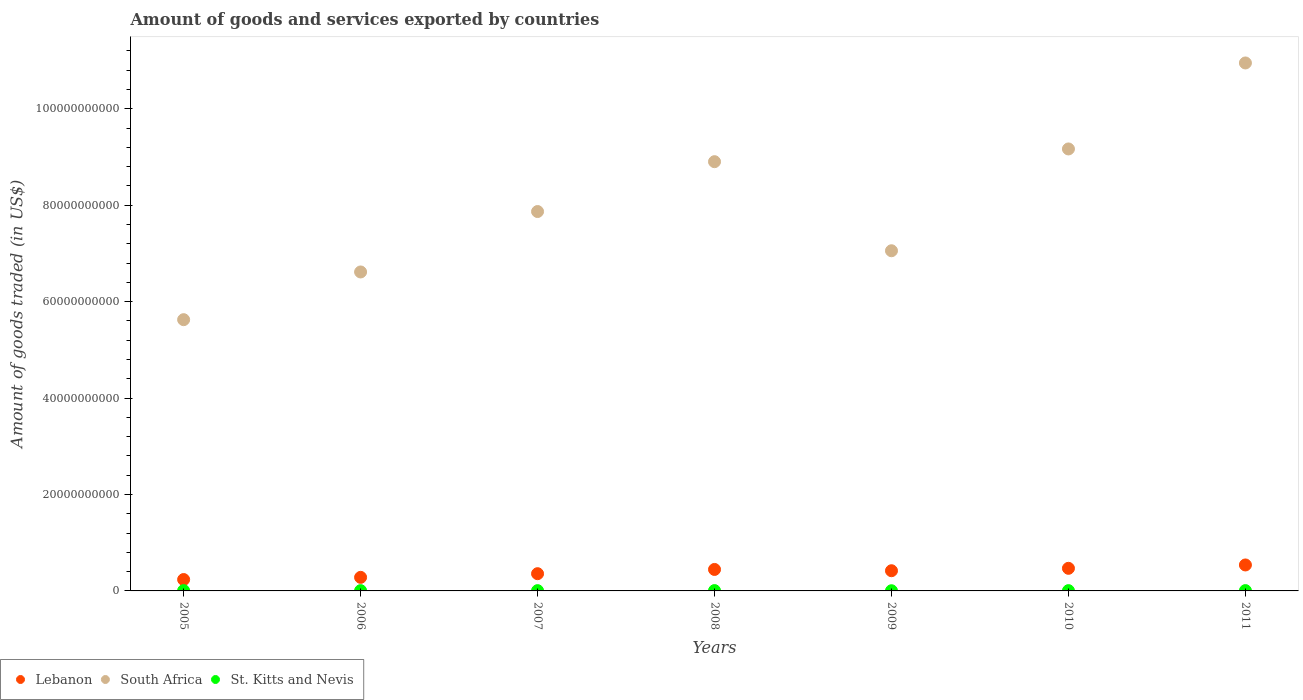What is the total amount of goods and services exported in Lebanon in 2011?
Provide a succinct answer. 5.39e+09. Across all years, what is the maximum total amount of goods and services exported in Lebanon?
Offer a very short reply. 5.39e+09. Across all years, what is the minimum total amount of goods and services exported in South Africa?
Make the answer very short. 5.63e+1. In which year was the total amount of goods and services exported in St. Kitts and Nevis maximum?
Provide a succinct answer. 2008. What is the total total amount of goods and services exported in South Africa in the graph?
Provide a succinct answer. 5.62e+11. What is the difference between the total amount of goods and services exported in Lebanon in 2008 and that in 2009?
Your answer should be very brief. 2.67e+08. What is the difference between the total amount of goods and services exported in St. Kitts and Nevis in 2005 and the total amount of goods and services exported in Lebanon in 2010?
Your answer should be very brief. -4.63e+09. What is the average total amount of goods and services exported in Lebanon per year?
Your answer should be compact. 3.92e+09. In the year 2005, what is the difference between the total amount of goods and services exported in South Africa and total amount of goods and services exported in Lebanon?
Give a very brief answer. 5.39e+1. What is the ratio of the total amount of goods and services exported in South Africa in 2010 to that in 2011?
Provide a short and direct response. 0.84. Is the difference between the total amount of goods and services exported in South Africa in 2007 and 2011 greater than the difference between the total amount of goods and services exported in Lebanon in 2007 and 2011?
Ensure brevity in your answer.  No. What is the difference between the highest and the second highest total amount of goods and services exported in St. Kitts and Nevis?
Your answer should be compact. 1.15e+06. What is the difference between the highest and the lowest total amount of goods and services exported in South Africa?
Keep it short and to the point. 5.32e+1. Is the sum of the total amount of goods and services exported in South Africa in 2005 and 2007 greater than the maximum total amount of goods and services exported in St. Kitts and Nevis across all years?
Your response must be concise. Yes. Is it the case that in every year, the sum of the total amount of goods and services exported in Lebanon and total amount of goods and services exported in St. Kitts and Nevis  is greater than the total amount of goods and services exported in South Africa?
Your response must be concise. No. Is the total amount of goods and services exported in St. Kitts and Nevis strictly greater than the total amount of goods and services exported in Lebanon over the years?
Your answer should be compact. No. Is the total amount of goods and services exported in Lebanon strictly less than the total amount of goods and services exported in St. Kitts and Nevis over the years?
Keep it short and to the point. No. How many dotlines are there?
Your answer should be compact. 3. How many years are there in the graph?
Make the answer very short. 7. What is the difference between two consecutive major ticks on the Y-axis?
Your response must be concise. 2.00e+1. Does the graph contain any zero values?
Make the answer very short. No. Does the graph contain grids?
Keep it short and to the point. No. How many legend labels are there?
Make the answer very short. 3. What is the title of the graph?
Your answer should be very brief. Amount of goods and services exported by countries. What is the label or title of the X-axis?
Offer a terse response. Years. What is the label or title of the Y-axis?
Ensure brevity in your answer.  Amount of goods traded (in US$). What is the Amount of goods traded (in US$) in Lebanon in 2005?
Give a very brief answer. 2.36e+09. What is the Amount of goods traded (in US$) in South Africa in 2005?
Your answer should be very brief. 5.63e+1. What is the Amount of goods traded (in US$) in St. Kitts and Nevis in 2005?
Provide a short and direct response. 6.34e+07. What is the Amount of goods traded (in US$) of Lebanon in 2006?
Your answer should be compact. 2.81e+09. What is the Amount of goods traded (in US$) of South Africa in 2006?
Make the answer very short. 6.62e+1. What is the Amount of goods traded (in US$) in St. Kitts and Nevis in 2006?
Your answer should be very brief. 5.82e+07. What is the Amount of goods traded (in US$) of Lebanon in 2007?
Your response must be concise. 3.57e+09. What is the Amount of goods traded (in US$) of South Africa in 2007?
Your answer should be compact. 7.87e+1. What is the Amount of goods traded (in US$) in St. Kitts and Nevis in 2007?
Make the answer very short. 5.75e+07. What is the Amount of goods traded (in US$) in Lebanon in 2008?
Provide a short and direct response. 4.45e+09. What is the Amount of goods traded (in US$) in South Africa in 2008?
Offer a very short reply. 8.90e+1. What is the Amount of goods traded (in US$) in St. Kitts and Nevis in 2008?
Give a very brief answer. 6.89e+07. What is the Amount of goods traded (in US$) of Lebanon in 2009?
Provide a succinct answer. 4.19e+09. What is the Amount of goods traded (in US$) of South Africa in 2009?
Offer a terse response. 7.06e+1. What is the Amount of goods traded (in US$) in St. Kitts and Nevis in 2009?
Ensure brevity in your answer.  3.74e+07. What is the Amount of goods traded (in US$) of Lebanon in 2010?
Keep it short and to the point. 4.69e+09. What is the Amount of goods traded (in US$) in South Africa in 2010?
Your answer should be very brief. 9.17e+1. What is the Amount of goods traded (in US$) in St. Kitts and Nevis in 2010?
Your answer should be compact. 5.79e+07. What is the Amount of goods traded (in US$) of Lebanon in 2011?
Offer a terse response. 5.39e+09. What is the Amount of goods traded (in US$) in South Africa in 2011?
Ensure brevity in your answer.  1.10e+11. What is the Amount of goods traded (in US$) of St. Kitts and Nevis in 2011?
Make the answer very short. 6.77e+07. Across all years, what is the maximum Amount of goods traded (in US$) of Lebanon?
Ensure brevity in your answer.  5.39e+09. Across all years, what is the maximum Amount of goods traded (in US$) in South Africa?
Offer a terse response. 1.10e+11. Across all years, what is the maximum Amount of goods traded (in US$) of St. Kitts and Nevis?
Give a very brief answer. 6.89e+07. Across all years, what is the minimum Amount of goods traded (in US$) in Lebanon?
Your response must be concise. 2.36e+09. Across all years, what is the minimum Amount of goods traded (in US$) in South Africa?
Your answer should be very brief. 5.63e+1. Across all years, what is the minimum Amount of goods traded (in US$) in St. Kitts and Nevis?
Offer a terse response. 3.74e+07. What is the total Amount of goods traded (in US$) in Lebanon in the graph?
Your response must be concise. 2.75e+1. What is the total Amount of goods traded (in US$) of South Africa in the graph?
Offer a very short reply. 5.62e+11. What is the total Amount of goods traded (in US$) of St. Kitts and Nevis in the graph?
Provide a succinct answer. 4.11e+08. What is the difference between the Amount of goods traded (in US$) in Lebanon in 2005 and that in 2006?
Provide a short and direct response. -4.53e+08. What is the difference between the Amount of goods traded (in US$) of South Africa in 2005 and that in 2006?
Offer a very short reply. -9.90e+09. What is the difference between the Amount of goods traded (in US$) in St. Kitts and Nevis in 2005 and that in 2006?
Your answer should be compact. 5.23e+06. What is the difference between the Amount of goods traded (in US$) of Lebanon in 2005 and that in 2007?
Your response must be concise. -1.21e+09. What is the difference between the Amount of goods traded (in US$) in South Africa in 2005 and that in 2007?
Make the answer very short. -2.24e+1. What is the difference between the Amount of goods traded (in US$) in St. Kitts and Nevis in 2005 and that in 2007?
Make the answer very short. 5.92e+06. What is the difference between the Amount of goods traded (in US$) of Lebanon in 2005 and that in 2008?
Make the answer very short. -2.09e+09. What is the difference between the Amount of goods traded (in US$) of South Africa in 2005 and that in 2008?
Your answer should be compact. -3.28e+1. What is the difference between the Amount of goods traded (in US$) in St. Kitts and Nevis in 2005 and that in 2008?
Your answer should be very brief. -5.43e+06. What is the difference between the Amount of goods traded (in US$) of Lebanon in 2005 and that in 2009?
Provide a short and direct response. -1.83e+09. What is the difference between the Amount of goods traded (in US$) in South Africa in 2005 and that in 2009?
Give a very brief answer. -1.43e+1. What is the difference between the Amount of goods traded (in US$) of St. Kitts and Nevis in 2005 and that in 2009?
Make the answer very short. 2.60e+07. What is the difference between the Amount of goods traded (in US$) of Lebanon in 2005 and that in 2010?
Provide a succinct answer. -2.33e+09. What is the difference between the Amount of goods traded (in US$) of South Africa in 2005 and that in 2010?
Offer a very short reply. -3.54e+1. What is the difference between the Amount of goods traded (in US$) of St. Kitts and Nevis in 2005 and that in 2010?
Your answer should be compact. 5.54e+06. What is the difference between the Amount of goods traded (in US$) in Lebanon in 2005 and that in 2011?
Make the answer very short. -3.02e+09. What is the difference between the Amount of goods traded (in US$) in South Africa in 2005 and that in 2011?
Make the answer very short. -5.32e+1. What is the difference between the Amount of goods traded (in US$) of St. Kitts and Nevis in 2005 and that in 2011?
Keep it short and to the point. -4.27e+06. What is the difference between the Amount of goods traded (in US$) of Lebanon in 2006 and that in 2007?
Offer a very short reply. -7.60e+08. What is the difference between the Amount of goods traded (in US$) in South Africa in 2006 and that in 2007?
Offer a terse response. -1.25e+1. What is the difference between the Amount of goods traded (in US$) in St. Kitts and Nevis in 2006 and that in 2007?
Your answer should be very brief. 6.88e+05. What is the difference between the Amount of goods traded (in US$) of Lebanon in 2006 and that in 2008?
Provide a short and direct response. -1.64e+09. What is the difference between the Amount of goods traded (in US$) in South Africa in 2006 and that in 2008?
Your answer should be compact. -2.29e+1. What is the difference between the Amount of goods traded (in US$) of St. Kitts and Nevis in 2006 and that in 2008?
Provide a succinct answer. -1.07e+07. What is the difference between the Amount of goods traded (in US$) of Lebanon in 2006 and that in 2009?
Your answer should be compact. -1.37e+09. What is the difference between the Amount of goods traded (in US$) in South Africa in 2006 and that in 2009?
Make the answer very short. -4.40e+09. What is the difference between the Amount of goods traded (in US$) in St. Kitts and Nevis in 2006 and that in 2009?
Your answer should be very brief. 2.08e+07. What is the difference between the Amount of goods traded (in US$) of Lebanon in 2006 and that in 2010?
Ensure brevity in your answer.  -1.87e+09. What is the difference between the Amount of goods traded (in US$) of South Africa in 2006 and that in 2010?
Your answer should be compact. -2.55e+1. What is the difference between the Amount of goods traded (in US$) of St. Kitts and Nevis in 2006 and that in 2010?
Your answer should be compact. 3.13e+05. What is the difference between the Amount of goods traded (in US$) of Lebanon in 2006 and that in 2011?
Your answer should be compact. -2.57e+09. What is the difference between the Amount of goods traded (in US$) of South Africa in 2006 and that in 2011?
Provide a short and direct response. -4.33e+1. What is the difference between the Amount of goods traded (in US$) of St. Kitts and Nevis in 2006 and that in 2011?
Keep it short and to the point. -9.50e+06. What is the difference between the Amount of goods traded (in US$) of Lebanon in 2007 and that in 2008?
Offer a very short reply. -8.79e+08. What is the difference between the Amount of goods traded (in US$) in South Africa in 2007 and that in 2008?
Provide a succinct answer. -1.03e+1. What is the difference between the Amount of goods traded (in US$) in St. Kitts and Nevis in 2007 and that in 2008?
Ensure brevity in your answer.  -1.13e+07. What is the difference between the Amount of goods traded (in US$) in Lebanon in 2007 and that in 2009?
Ensure brevity in your answer.  -6.13e+08. What is the difference between the Amount of goods traded (in US$) in South Africa in 2007 and that in 2009?
Make the answer very short. 8.14e+09. What is the difference between the Amount of goods traded (in US$) in St. Kitts and Nevis in 2007 and that in 2009?
Provide a succinct answer. 2.01e+07. What is the difference between the Amount of goods traded (in US$) in Lebanon in 2007 and that in 2010?
Offer a terse response. -1.11e+09. What is the difference between the Amount of goods traded (in US$) of South Africa in 2007 and that in 2010?
Ensure brevity in your answer.  -1.30e+1. What is the difference between the Amount of goods traded (in US$) of St. Kitts and Nevis in 2007 and that in 2010?
Provide a short and direct response. -3.75e+05. What is the difference between the Amount of goods traded (in US$) of Lebanon in 2007 and that in 2011?
Keep it short and to the point. -1.81e+09. What is the difference between the Amount of goods traded (in US$) of South Africa in 2007 and that in 2011?
Provide a short and direct response. -3.08e+1. What is the difference between the Amount of goods traded (in US$) of St. Kitts and Nevis in 2007 and that in 2011?
Ensure brevity in your answer.  -1.02e+07. What is the difference between the Amount of goods traded (in US$) in Lebanon in 2008 and that in 2009?
Your response must be concise. 2.67e+08. What is the difference between the Amount of goods traded (in US$) in South Africa in 2008 and that in 2009?
Give a very brief answer. 1.85e+1. What is the difference between the Amount of goods traded (in US$) in St. Kitts and Nevis in 2008 and that in 2009?
Provide a short and direct response. 3.14e+07. What is the difference between the Amount of goods traded (in US$) in Lebanon in 2008 and that in 2010?
Keep it short and to the point. -2.35e+08. What is the difference between the Amount of goods traded (in US$) in South Africa in 2008 and that in 2010?
Make the answer very short. -2.64e+09. What is the difference between the Amount of goods traded (in US$) of St. Kitts and Nevis in 2008 and that in 2010?
Offer a terse response. 1.10e+07. What is the difference between the Amount of goods traded (in US$) in Lebanon in 2008 and that in 2011?
Your response must be concise. -9.32e+08. What is the difference between the Amount of goods traded (in US$) in South Africa in 2008 and that in 2011?
Provide a short and direct response. -2.05e+1. What is the difference between the Amount of goods traded (in US$) in St. Kitts and Nevis in 2008 and that in 2011?
Your answer should be very brief. 1.15e+06. What is the difference between the Amount of goods traded (in US$) in Lebanon in 2009 and that in 2010?
Your answer should be compact. -5.02e+08. What is the difference between the Amount of goods traded (in US$) of South Africa in 2009 and that in 2010?
Your answer should be very brief. -2.11e+1. What is the difference between the Amount of goods traded (in US$) in St. Kitts and Nevis in 2009 and that in 2010?
Offer a terse response. -2.05e+07. What is the difference between the Amount of goods traded (in US$) of Lebanon in 2009 and that in 2011?
Provide a succinct answer. -1.20e+09. What is the difference between the Amount of goods traded (in US$) in South Africa in 2009 and that in 2011?
Your answer should be compact. -3.90e+1. What is the difference between the Amount of goods traded (in US$) of St. Kitts and Nevis in 2009 and that in 2011?
Provide a succinct answer. -3.03e+07. What is the difference between the Amount of goods traded (in US$) of Lebanon in 2010 and that in 2011?
Your response must be concise. -6.97e+08. What is the difference between the Amount of goods traded (in US$) in South Africa in 2010 and that in 2011?
Keep it short and to the point. -1.78e+1. What is the difference between the Amount of goods traded (in US$) of St. Kitts and Nevis in 2010 and that in 2011?
Provide a succinct answer. -9.81e+06. What is the difference between the Amount of goods traded (in US$) in Lebanon in 2005 and the Amount of goods traded (in US$) in South Africa in 2006?
Make the answer very short. -6.38e+1. What is the difference between the Amount of goods traded (in US$) in Lebanon in 2005 and the Amount of goods traded (in US$) in St. Kitts and Nevis in 2006?
Keep it short and to the point. 2.30e+09. What is the difference between the Amount of goods traded (in US$) in South Africa in 2005 and the Amount of goods traded (in US$) in St. Kitts and Nevis in 2006?
Your response must be concise. 5.62e+1. What is the difference between the Amount of goods traded (in US$) of Lebanon in 2005 and the Amount of goods traded (in US$) of South Africa in 2007?
Offer a terse response. -7.63e+1. What is the difference between the Amount of goods traded (in US$) of Lebanon in 2005 and the Amount of goods traded (in US$) of St. Kitts and Nevis in 2007?
Offer a terse response. 2.30e+09. What is the difference between the Amount of goods traded (in US$) of South Africa in 2005 and the Amount of goods traded (in US$) of St. Kitts and Nevis in 2007?
Offer a very short reply. 5.62e+1. What is the difference between the Amount of goods traded (in US$) in Lebanon in 2005 and the Amount of goods traded (in US$) in South Africa in 2008?
Your response must be concise. -8.67e+1. What is the difference between the Amount of goods traded (in US$) of Lebanon in 2005 and the Amount of goods traded (in US$) of St. Kitts and Nevis in 2008?
Offer a terse response. 2.29e+09. What is the difference between the Amount of goods traded (in US$) in South Africa in 2005 and the Amount of goods traded (in US$) in St. Kitts and Nevis in 2008?
Ensure brevity in your answer.  5.62e+1. What is the difference between the Amount of goods traded (in US$) in Lebanon in 2005 and the Amount of goods traded (in US$) in South Africa in 2009?
Make the answer very short. -6.82e+1. What is the difference between the Amount of goods traded (in US$) in Lebanon in 2005 and the Amount of goods traded (in US$) in St. Kitts and Nevis in 2009?
Keep it short and to the point. 2.32e+09. What is the difference between the Amount of goods traded (in US$) in South Africa in 2005 and the Amount of goods traded (in US$) in St. Kitts and Nevis in 2009?
Provide a short and direct response. 5.62e+1. What is the difference between the Amount of goods traded (in US$) of Lebanon in 2005 and the Amount of goods traded (in US$) of South Africa in 2010?
Offer a terse response. -8.93e+1. What is the difference between the Amount of goods traded (in US$) of Lebanon in 2005 and the Amount of goods traded (in US$) of St. Kitts and Nevis in 2010?
Your answer should be very brief. 2.30e+09. What is the difference between the Amount of goods traded (in US$) of South Africa in 2005 and the Amount of goods traded (in US$) of St. Kitts and Nevis in 2010?
Your response must be concise. 5.62e+1. What is the difference between the Amount of goods traded (in US$) of Lebanon in 2005 and the Amount of goods traded (in US$) of South Africa in 2011?
Provide a succinct answer. -1.07e+11. What is the difference between the Amount of goods traded (in US$) in Lebanon in 2005 and the Amount of goods traded (in US$) in St. Kitts and Nevis in 2011?
Make the answer very short. 2.29e+09. What is the difference between the Amount of goods traded (in US$) of South Africa in 2005 and the Amount of goods traded (in US$) of St. Kitts and Nevis in 2011?
Your answer should be compact. 5.62e+1. What is the difference between the Amount of goods traded (in US$) in Lebanon in 2006 and the Amount of goods traded (in US$) in South Africa in 2007?
Offer a very short reply. -7.59e+1. What is the difference between the Amount of goods traded (in US$) in Lebanon in 2006 and the Amount of goods traded (in US$) in St. Kitts and Nevis in 2007?
Give a very brief answer. 2.76e+09. What is the difference between the Amount of goods traded (in US$) in South Africa in 2006 and the Amount of goods traded (in US$) in St. Kitts and Nevis in 2007?
Provide a succinct answer. 6.61e+1. What is the difference between the Amount of goods traded (in US$) of Lebanon in 2006 and the Amount of goods traded (in US$) of South Africa in 2008?
Provide a succinct answer. -8.62e+1. What is the difference between the Amount of goods traded (in US$) of Lebanon in 2006 and the Amount of goods traded (in US$) of St. Kitts and Nevis in 2008?
Keep it short and to the point. 2.74e+09. What is the difference between the Amount of goods traded (in US$) of South Africa in 2006 and the Amount of goods traded (in US$) of St. Kitts and Nevis in 2008?
Provide a succinct answer. 6.61e+1. What is the difference between the Amount of goods traded (in US$) in Lebanon in 2006 and the Amount of goods traded (in US$) in South Africa in 2009?
Make the answer very short. -6.77e+1. What is the difference between the Amount of goods traded (in US$) in Lebanon in 2006 and the Amount of goods traded (in US$) in St. Kitts and Nevis in 2009?
Your response must be concise. 2.78e+09. What is the difference between the Amount of goods traded (in US$) of South Africa in 2006 and the Amount of goods traded (in US$) of St. Kitts and Nevis in 2009?
Offer a terse response. 6.61e+1. What is the difference between the Amount of goods traded (in US$) in Lebanon in 2006 and the Amount of goods traded (in US$) in South Africa in 2010?
Provide a short and direct response. -8.89e+1. What is the difference between the Amount of goods traded (in US$) of Lebanon in 2006 and the Amount of goods traded (in US$) of St. Kitts and Nevis in 2010?
Your response must be concise. 2.76e+09. What is the difference between the Amount of goods traded (in US$) of South Africa in 2006 and the Amount of goods traded (in US$) of St. Kitts and Nevis in 2010?
Keep it short and to the point. 6.61e+1. What is the difference between the Amount of goods traded (in US$) of Lebanon in 2006 and the Amount of goods traded (in US$) of South Africa in 2011?
Your response must be concise. -1.07e+11. What is the difference between the Amount of goods traded (in US$) of Lebanon in 2006 and the Amount of goods traded (in US$) of St. Kitts and Nevis in 2011?
Ensure brevity in your answer.  2.75e+09. What is the difference between the Amount of goods traded (in US$) in South Africa in 2006 and the Amount of goods traded (in US$) in St. Kitts and Nevis in 2011?
Make the answer very short. 6.61e+1. What is the difference between the Amount of goods traded (in US$) in Lebanon in 2007 and the Amount of goods traded (in US$) in South Africa in 2008?
Provide a short and direct response. -8.55e+1. What is the difference between the Amount of goods traded (in US$) in Lebanon in 2007 and the Amount of goods traded (in US$) in St. Kitts and Nevis in 2008?
Your response must be concise. 3.51e+09. What is the difference between the Amount of goods traded (in US$) of South Africa in 2007 and the Amount of goods traded (in US$) of St. Kitts and Nevis in 2008?
Ensure brevity in your answer.  7.86e+1. What is the difference between the Amount of goods traded (in US$) in Lebanon in 2007 and the Amount of goods traded (in US$) in South Africa in 2009?
Your response must be concise. -6.70e+1. What is the difference between the Amount of goods traded (in US$) in Lebanon in 2007 and the Amount of goods traded (in US$) in St. Kitts and Nevis in 2009?
Ensure brevity in your answer.  3.54e+09. What is the difference between the Amount of goods traded (in US$) in South Africa in 2007 and the Amount of goods traded (in US$) in St. Kitts and Nevis in 2009?
Give a very brief answer. 7.87e+1. What is the difference between the Amount of goods traded (in US$) of Lebanon in 2007 and the Amount of goods traded (in US$) of South Africa in 2010?
Offer a terse response. -8.81e+1. What is the difference between the Amount of goods traded (in US$) of Lebanon in 2007 and the Amount of goods traded (in US$) of St. Kitts and Nevis in 2010?
Provide a short and direct response. 3.52e+09. What is the difference between the Amount of goods traded (in US$) in South Africa in 2007 and the Amount of goods traded (in US$) in St. Kitts and Nevis in 2010?
Your answer should be very brief. 7.86e+1. What is the difference between the Amount of goods traded (in US$) in Lebanon in 2007 and the Amount of goods traded (in US$) in South Africa in 2011?
Provide a succinct answer. -1.06e+11. What is the difference between the Amount of goods traded (in US$) in Lebanon in 2007 and the Amount of goods traded (in US$) in St. Kitts and Nevis in 2011?
Your answer should be very brief. 3.51e+09. What is the difference between the Amount of goods traded (in US$) in South Africa in 2007 and the Amount of goods traded (in US$) in St. Kitts and Nevis in 2011?
Keep it short and to the point. 7.86e+1. What is the difference between the Amount of goods traded (in US$) in Lebanon in 2008 and the Amount of goods traded (in US$) in South Africa in 2009?
Keep it short and to the point. -6.61e+1. What is the difference between the Amount of goods traded (in US$) of Lebanon in 2008 and the Amount of goods traded (in US$) of St. Kitts and Nevis in 2009?
Offer a terse response. 4.42e+09. What is the difference between the Amount of goods traded (in US$) in South Africa in 2008 and the Amount of goods traded (in US$) in St. Kitts and Nevis in 2009?
Offer a terse response. 8.90e+1. What is the difference between the Amount of goods traded (in US$) of Lebanon in 2008 and the Amount of goods traded (in US$) of South Africa in 2010?
Your answer should be compact. -8.72e+1. What is the difference between the Amount of goods traded (in US$) in Lebanon in 2008 and the Amount of goods traded (in US$) in St. Kitts and Nevis in 2010?
Your answer should be compact. 4.40e+09. What is the difference between the Amount of goods traded (in US$) of South Africa in 2008 and the Amount of goods traded (in US$) of St. Kitts and Nevis in 2010?
Give a very brief answer. 8.90e+1. What is the difference between the Amount of goods traded (in US$) in Lebanon in 2008 and the Amount of goods traded (in US$) in South Africa in 2011?
Your answer should be compact. -1.05e+11. What is the difference between the Amount of goods traded (in US$) of Lebanon in 2008 and the Amount of goods traded (in US$) of St. Kitts and Nevis in 2011?
Your answer should be compact. 4.39e+09. What is the difference between the Amount of goods traded (in US$) of South Africa in 2008 and the Amount of goods traded (in US$) of St. Kitts and Nevis in 2011?
Make the answer very short. 8.90e+1. What is the difference between the Amount of goods traded (in US$) of Lebanon in 2009 and the Amount of goods traded (in US$) of South Africa in 2010?
Make the answer very short. -8.75e+1. What is the difference between the Amount of goods traded (in US$) in Lebanon in 2009 and the Amount of goods traded (in US$) in St. Kitts and Nevis in 2010?
Offer a terse response. 4.13e+09. What is the difference between the Amount of goods traded (in US$) in South Africa in 2009 and the Amount of goods traded (in US$) in St. Kitts and Nevis in 2010?
Provide a succinct answer. 7.05e+1. What is the difference between the Amount of goods traded (in US$) in Lebanon in 2009 and the Amount of goods traded (in US$) in South Africa in 2011?
Your answer should be compact. -1.05e+11. What is the difference between the Amount of goods traded (in US$) of Lebanon in 2009 and the Amount of goods traded (in US$) of St. Kitts and Nevis in 2011?
Your answer should be compact. 4.12e+09. What is the difference between the Amount of goods traded (in US$) of South Africa in 2009 and the Amount of goods traded (in US$) of St. Kitts and Nevis in 2011?
Make the answer very short. 7.05e+1. What is the difference between the Amount of goods traded (in US$) in Lebanon in 2010 and the Amount of goods traded (in US$) in South Africa in 2011?
Offer a terse response. -1.05e+11. What is the difference between the Amount of goods traded (in US$) in Lebanon in 2010 and the Amount of goods traded (in US$) in St. Kitts and Nevis in 2011?
Offer a terse response. 4.62e+09. What is the difference between the Amount of goods traded (in US$) of South Africa in 2010 and the Amount of goods traded (in US$) of St. Kitts and Nevis in 2011?
Make the answer very short. 9.16e+1. What is the average Amount of goods traded (in US$) of Lebanon per year?
Your answer should be compact. 3.92e+09. What is the average Amount of goods traded (in US$) in South Africa per year?
Your answer should be very brief. 8.03e+1. What is the average Amount of goods traded (in US$) of St. Kitts and Nevis per year?
Give a very brief answer. 5.87e+07. In the year 2005, what is the difference between the Amount of goods traded (in US$) of Lebanon and Amount of goods traded (in US$) of South Africa?
Your answer should be very brief. -5.39e+1. In the year 2005, what is the difference between the Amount of goods traded (in US$) of Lebanon and Amount of goods traded (in US$) of St. Kitts and Nevis?
Make the answer very short. 2.30e+09. In the year 2005, what is the difference between the Amount of goods traded (in US$) in South Africa and Amount of goods traded (in US$) in St. Kitts and Nevis?
Provide a short and direct response. 5.62e+1. In the year 2006, what is the difference between the Amount of goods traded (in US$) in Lebanon and Amount of goods traded (in US$) in South Africa?
Offer a very short reply. -6.33e+1. In the year 2006, what is the difference between the Amount of goods traded (in US$) of Lebanon and Amount of goods traded (in US$) of St. Kitts and Nevis?
Provide a short and direct response. 2.76e+09. In the year 2006, what is the difference between the Amount of goods traded (in US$) of South Africa and Amount of goods traded (in US$) of St. Kitts and Nevis?
Provide a succinct answer. 6.61e+1. In the year 2007, what is the difference between the Amount of goods traded (in US$) of Lebanon and Amount of goods traded (in US$) of South Africa?
Your answer should be very brief. -7.51e+1. In the year 2007, what is the difference between the Amount of goods traded (in US$) in Lebanon and Amount of goods traded (in US$) in St. Kitts and Nevis?
Give a very brief answer. 3.52e+09. In the year 2007, what is the difference between the Amount of goods traded (in US$) of South Africa and Amount of goods traded (in US$) of St. Kitts and Nevis?
Keep it short and to the point. 7.86e+1. In the year 2008, what is the difference between the Amount of goods traded (in US$) of Lebanon and Amount of goods traded (in US$) of South Africa?
Offer a very short reply. -8.46e+1. In the year 2008, what is the difference between the Amount of goods traded (in US$) of Lebanon and Amount of goods traded (in US$) of St. Kitts and Nevis?
Your response must be concise. 4.38e+09. In the year 2008, what is the difference between the Amount of goods traded (in US$) in South Africa and Amount of goods traded (in US$) in St. Kitts and Nevis?
Offer a very short reply. 8.90e+1. In the year 2009, what is the difference between the Amount of goods traded (in US$) of Lebanon and Amount of goods traded (in US$) of South Africa?
Keep it short and to the point. -6.64e+1. In the year 2009, what is the difference between the Amount of goods traded (in US$) in Lebanon and Amount of goods traded (in US$) in St. Kitts and Nevis?
Ensure brevity in your answer.  4.15e+09. In the year 2009, what is the difference between the Amount of goods traded (in US$) of South Africa and Amount of goods traded (in US$) of St. Kitts and Nevis?
Provide a succinct answer. 7.05e+1. In the year 2010, what is the difference between the Amount of goods traded (in US$) in Lebanon and Amount of goods traded (in US$) in South Africa?
Provide a short and direct response. -8.70e+1. In the year 2010, what is the difference between the Amount of goods traded (in US$) in Lebanon and Amount of goods traded (in US$) in St. Kitts and Nevis?
Your answer should be very brief. 4.63e+09. In the year 2010, what is the difference between the Amount of goods traded (in US$) of South Africa and Amount of goods traded (in US$) of St. Kitts and Nevis?
Provide a short and direct response. 9.16e+1. In the year 2011, what is the difference between the Amount of goods traded (in US$) in Lebanon and Amount of goods traded (in US$) in South Africa?
Offer a terse response. -1.04e+11. In the year 2011, what is the difference between the Amount of goods traded (in US$) in Lebanon and Amount of goods traded (in US$) in St. Kitts and Nevis?
Ensure brevity in your answer.  5.32e+09. In the year 2011, what is the difference between the Amount of goods traded (in US$) in South Africa and Amount of goods traded (in US$) in St. Kitts and Nevis?
Your answer should be compact. 1.09e+11. What is the ratio of the Amount of goods traded (in US$) of Lebanon in 2005 to that in 2006?
Your answer should be compact. 0.84. What is the ratio of the Amount of goods traded (in US$) in South Africa in 2005 to that in 2006?
Make the answer very short. 0.85. What is the ratio of the Amount of goods traded (in US$) in St. Kitts and Nevis in 2005 to that in 2006?
Keep it short and to the point. 1.09. What is the ratio of the Amount of goods traded (in US$) in Lebanon in 2005 to that in 2007?
Your answer should be compact. 0.66. What is the ratio of the Amount of goods traded (in US$) of South Africa in 2005 to that in 2007?
Offer a terse response. 0.71. What is the ratio of the Amount of goods traded (in US$) in St. Kitts and Nevis in 2005 to that in 2007?
Give a very brief answer. 1.1. What is the ratio of the Amount of goods traded (in US$) of Lebanon in 2005 to that in 2008?
Make the answer very short. 0.53. What is the ratio of the Amount of goods traded (in US$) in South Africa in 2005 to that in 2008?
Ensure brevity in your answer.  0.63. What is the ratio of the Amount of goods traded (in US$) in St. Kitts and Nevis in 2005 to that in 2008?
Your answer should be compact. 0.92. What is the ratio of the Amount of goods traded (in US$) in Lebanon in 2005 to that in 2009?
Your response must be concise. 0.56. What is the ratio of the Amount of goods traded (in US$) of South Africa in 2005 to that in 2009?
Offer a very short reply. 0.8. What is the ratio of the Amount of goods traded (in US$) in St. Kitts and Nevis in 2005 to that in 2009?
Give a very brief answer. 1.69. What is the ratio of the Amount of goods traded (in US$) of Lebanon in 2005 to that in 2010?
Your answer should be compact. 0.5. What is the ratio of the Amount of goods traded (in US$) in South Africa in 2005 to that in 2010?
Give a very brief answer. 0.61. What is the ratio of the Amount of goods traded (in US$) of St. Kitts and Nevis in 2005 to that in 2010?
Ensure brevity in your answer.  1.1. What is the ratio of the Amount of goods traded (in US$) in Lebanon in 2005 to that in 2011?
Keep it short and to the point. 0.44. What is the ratio of the Amount of goods traded (in US$) in South Africa in 2005 to that in 2011?
Your answer should be very brief. 0.51. What is the ratio of the Amount of goods traded (in US$) of St. Kitts and Nevis in 2005 to that in 2011?
Offer a very short reply. 0.94. What is the ratio of the Amount of goods traded (in US$) in Lebanon in 2006 to that in 2007?
Your answer should be very brief. 0.79. What is the ratio of the Amount of goods traded (in US$) in South Africa in 2006 to that in 2007?
Provide a short and direct response. 0.84. What is the ratio of the Amount of goods traded (in US$) of St. Kitts and Nevis in 2006 to that in 2007?
Offer a terse response. 1.01. What is the ratio of the Amount of goods traded (in US$) in Lebanon in 2006 to that in 2008?
Keep it short and to the point. 0.63. What is the ratio of the Amount of goods traded (in US$) of South Africa in 2006 to that in 2008?
Offer a terse response. 0.74. What is the ratio of the Amount of goods traded (in US$) of St. Kitts and Nevis in 2006 to that in 2008?
Offer a very short reply. 0.85. What is the ratio of the Amount of goods traded (in US$) of Lebanon in 2006 to that in 2009?
Give a very brief answer. 0.67. What is the ratio of the Amount of goods traded (in US$) of South Africa in 2006 to that in 2009?
Your answer should be very brief. 0.94. What is the ratio of the Amount of goods traded (in US$) of St. Kitts and Nevis in 2006 to that in 2009?
Ensure brevity in your answer.  1.55. What is the ratio of the Amount of goods traded (in US$) in Lebanon in 2006 to that in 2010?
Provide a succinct answer. 0.6. What is the ratio of the Amount of goods traded (in US$) of South Africa in 2006 to that in 2010?
Your answer should be compact. 0.72. What is the ratio of the Amount of goods traded (in US$) in St. Kitts and Nevis in 2006 to that in 2010?
Keep it short and to the point. 1.01. What is the ratio of the Amount of goods traded (in US$) in Lebanon in 2006 to that in 2011?
Ensure brevity in your answer.  0.52. What is the ratio of the Amount of goods traded (in US$) in South Africa in 2006 to that in 2011?
Your response must be concise. 0.6. What is the ratio of the Amount of goods traded (in US$) of St. Kitts and Nevis in 2006 to that in 2011?
Make the answer very short. 0.86. What is the ratio of the Amount of goods traded (in US$) in Lebanon in 2007 to that in 2008?
Offer a terse response. 0.8. What is the ratio of the Amount of goods traded (in US$) in South Africa in 2007 to that in 2008?
Offer a terse response. 0.88. What is the ratio of the Amount of goods traded (in US$) of St. Kitts and Nevis in 2007 to that in 2008?
Offer a very short reply. 0.84. What is the ratio of the Amount of goods traded (in US$) of Lebanon in 2007 to that in 2009?
Make the answer very short. 0.85. What is the ratio of the Amount of goods traded (in US$) in South Africa in 2007 to that in 2009?
Provide a short and direct response. 1.12. What is the ratio of the Amount of goods traded (in US$) in St. Kitts and Nevis in 2007 to that in 2009?
Ensure brevity in your answer.  1.54. What is the ratio of the Amount of goods traded (in US$) in Lebanon in 2007 to that in 2010?
Your response must be concise. 0.76. What is the ratio of the Amount of goods traded (in US$) in South Africa in 2007 to that in 2010?
Your answer should be compact. 0.86. What is the ratio of the Amount of goods traded (in US$) of Lebanon in 2007 to that in 2011?
Give a very brief answer. 0.66. What is the ratio of the Amount of goods traded (in US$) in South Africa in 2007 to that in 2011?
Your answer should be compact. 0.72. What is the ratio of the Amount of goods traded (in US$) of St. Kitts and Nevis in 2007 to that in 2011?
Provide a succinct answer. 0.85. What is the ratio of the Amount of goods traded (in US$) of Lebanon in 2008 to that in 2009?
Make the answer very short. 1.06. What is the ratio of the Amount of goods traded (in US$) in South Africa in 2008 to that in 2009?
Your response must be concise. 1.26. What is the ratio of the Amount of goods traded (in US$) of St. Kitts and Nevis in 2008 to that in 2009?
Ensure brevity in your answer.  1.84. What is the ratio of the Amount of goods traded (in US$) in Lebanon in 2008 to that in 2010?
Keep it short and to the point. 0.95. What is the ratio of the Amount of goods traded (in US$) in South Africa in 2008 to that in 2010?
Offer a very short reply. 0.97. What is the ratio of the Amount of goods traded (in US$) in St. Kitts and Nevis in 2008 to that in 2010?
Offer a terse response. 1.19. What is the ratio of the Amount of goods traded (in US$) in Lebanon in 2008 to that in 2011?
Your response must be concise. 0.83. What is the ratio of the Amount of goods traded (in US$) in South Africa in 2008 to that in 2011?
Provide a succinct answer. 0.81. What is the ratio of the Amount of goods traded (in US$) of Lebanon in 2009 to that in 2010?
Keep it short and to the point. 0.89. What is the ratio of the Amount of goods traded (in US$) in South Africa in 2009 to that in 2010?
Your answer should be very brief. 0.77. What is the ratio of the Amount of goods traded (in US$) of St. Kitts and Nevis in 2009 to that in 2010?
Your answer should be very brief. 0.65. What is the ratio of the Amount of goods traded (in US$) of Lebanon in 2009 to that in 2011?
Give a very brief answer. 0.78. What is the ratio of the Amount of goods traded (in US$) of South Africa in 2009 to that in 2011?
Provide a short and direct response. 0.64. What is the ratio of the Amount of goods traded (in US$) of St. Kitts and Nevis in 2009 to that in 2011?
Your response must be concise. 0.55. What is the ratio of the Amount of goods traded (in US$) of Lebanon in 2010 to that in 2011?
Your answer should be compact. 0.87. What is the ratio of the Amount of goods traded (in US$) in South Africa in 2010 to that in 2011?
Your response must be concise. 0.84. What is the ratio of the Amount of goods traded (in US$) of St. Kitts and Nevis in 2010 to that in 2011?
Ensure brevity in your answer.  0.86. What is the difference between the highest and the second highest Amount of goods traded (in US$) of Lebanon?
Keep it short and to the point. 6.97e+08. What is the difference between the highest and the second highest Amount of goods traded (in US$) in South Africa?
Your response must be concise. 1.78e+1. What is the difference between the highest and the second highest Amount of goods traded (in US$) in St. Kitts and Nevis?
Your response must be concise. 1.15e+06. What is the difference between the highest and the lowest Amount of goods traded (in US$) in Lebanon?
Provide a succinct answer. 3.02e+09. What is the difference between the highest and the lowest Amount of goods traded (in US$) in South Africa?
Ensure brevity in your answer.  5.32e+1. What is the difference between the highest and the lowest Amount of goods traded (in US$) in St. Kitts and Nevis?
Offer a terse response. 3.14e+07. 